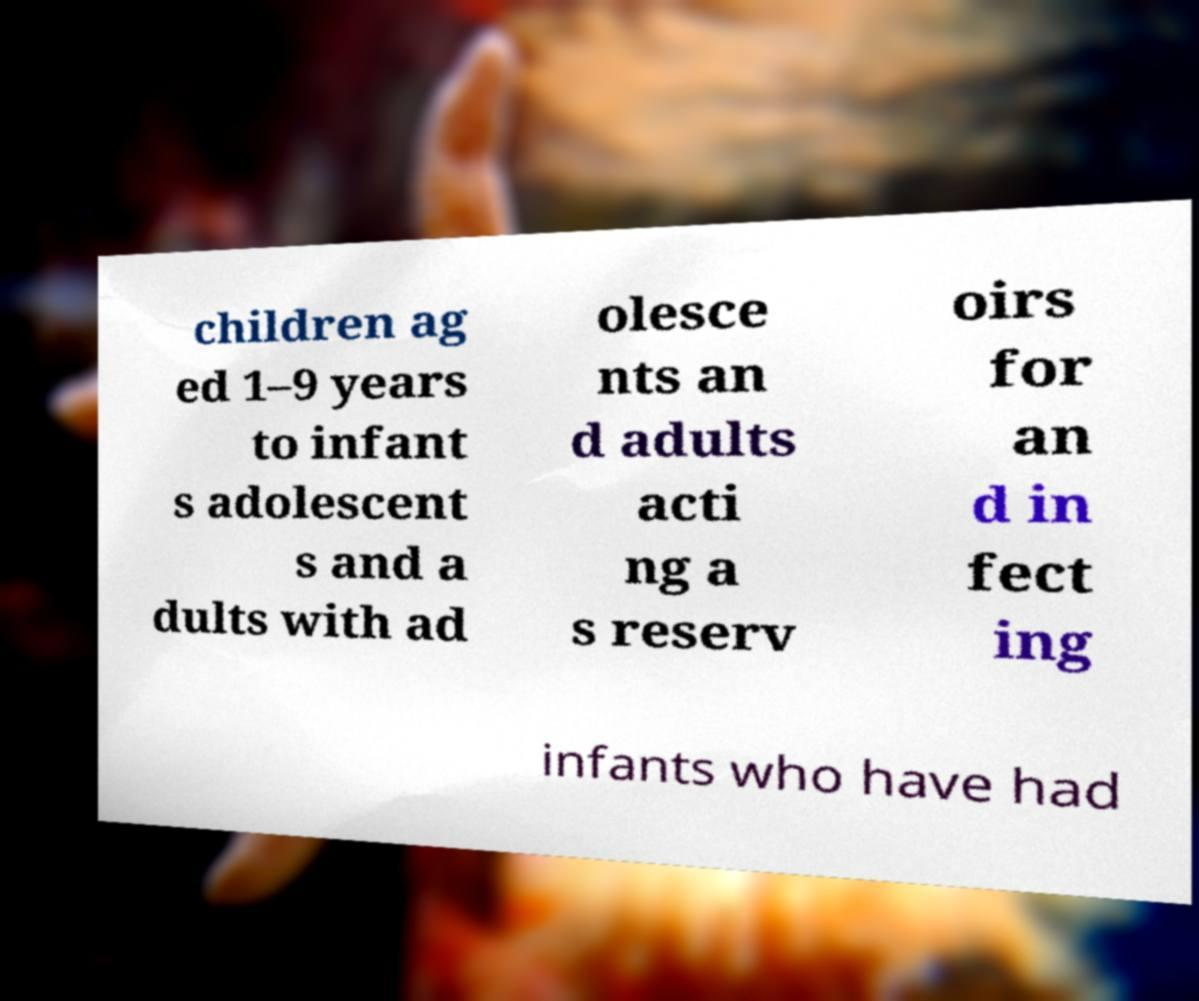Please read and relay the text visible in this image. What does it say? children ag ed 1–9 years to infant s adolescent s and a dults with ad olesce nts an d adults acti ng a s reserv oirs for an d in fect ing infants who have had 